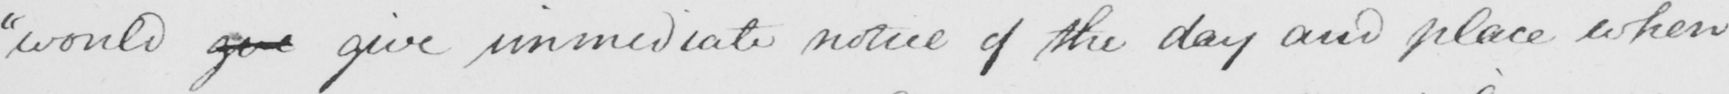Please provide the text content of this handwritten line. "would get give immediate notice of the day and place when 